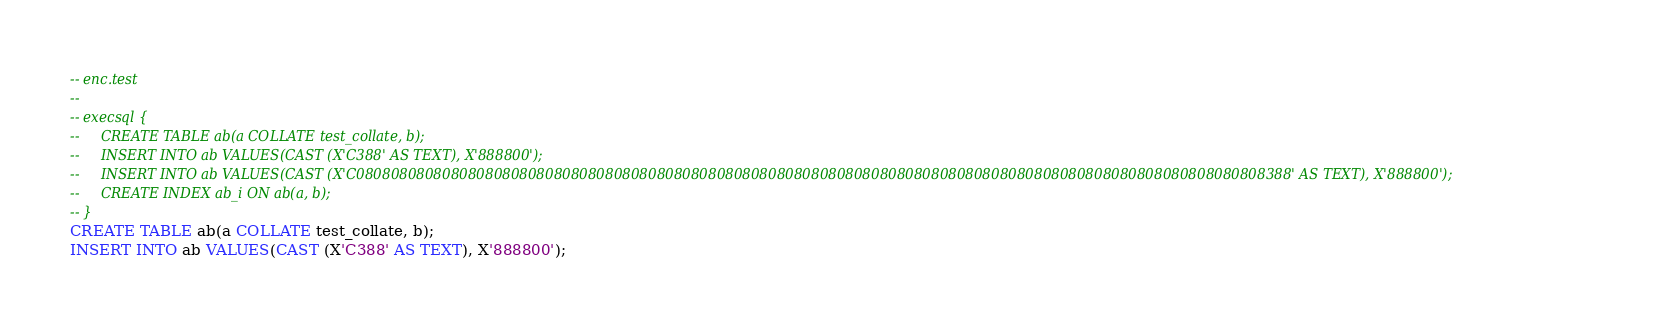<code> <loc_0><loc_0><loc_500><loc_500><_SQL_>-- enc.test
-- 
-- execsql {
--     CREATE TABLE ab(a COLLATE test_collate, b);
--     INSERT INTO ab VALUES(CAST (X'C388' AS TEXT), X'888800');
--     INSERT INTO ab VALUES(CAST (X'C0808080808080808080808080808080808080808080808080808080808080808080808080808080808080808080808080808080808388' AS TEXT), X'888800');
--     CREATE INDEX ab_i ON ab(a, b);
-- }
CREATE TABLE ab(a COLLATE test_collate, b);
INSERT INTO ab VALUES(CAST (X'C388' AS TEXT), X'888800');</code> 